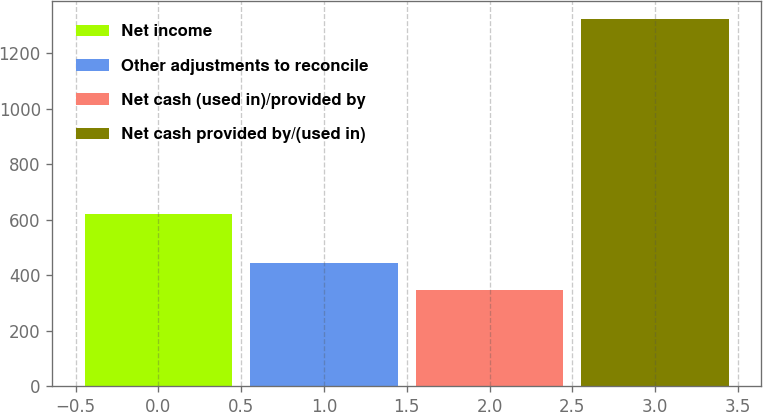<chart> <loc_0><loc_0><loc_500><loc_500><bar_chart><fcel>Net income<fcel>Other adjustments to reconcile<fcel>Net cash (used in)/provided by<fcel>Net cash provided by/(used in)<nl><fcel>622<fcel>445.5<fcel>348.1<fcel>1322.1<nl></chart> 